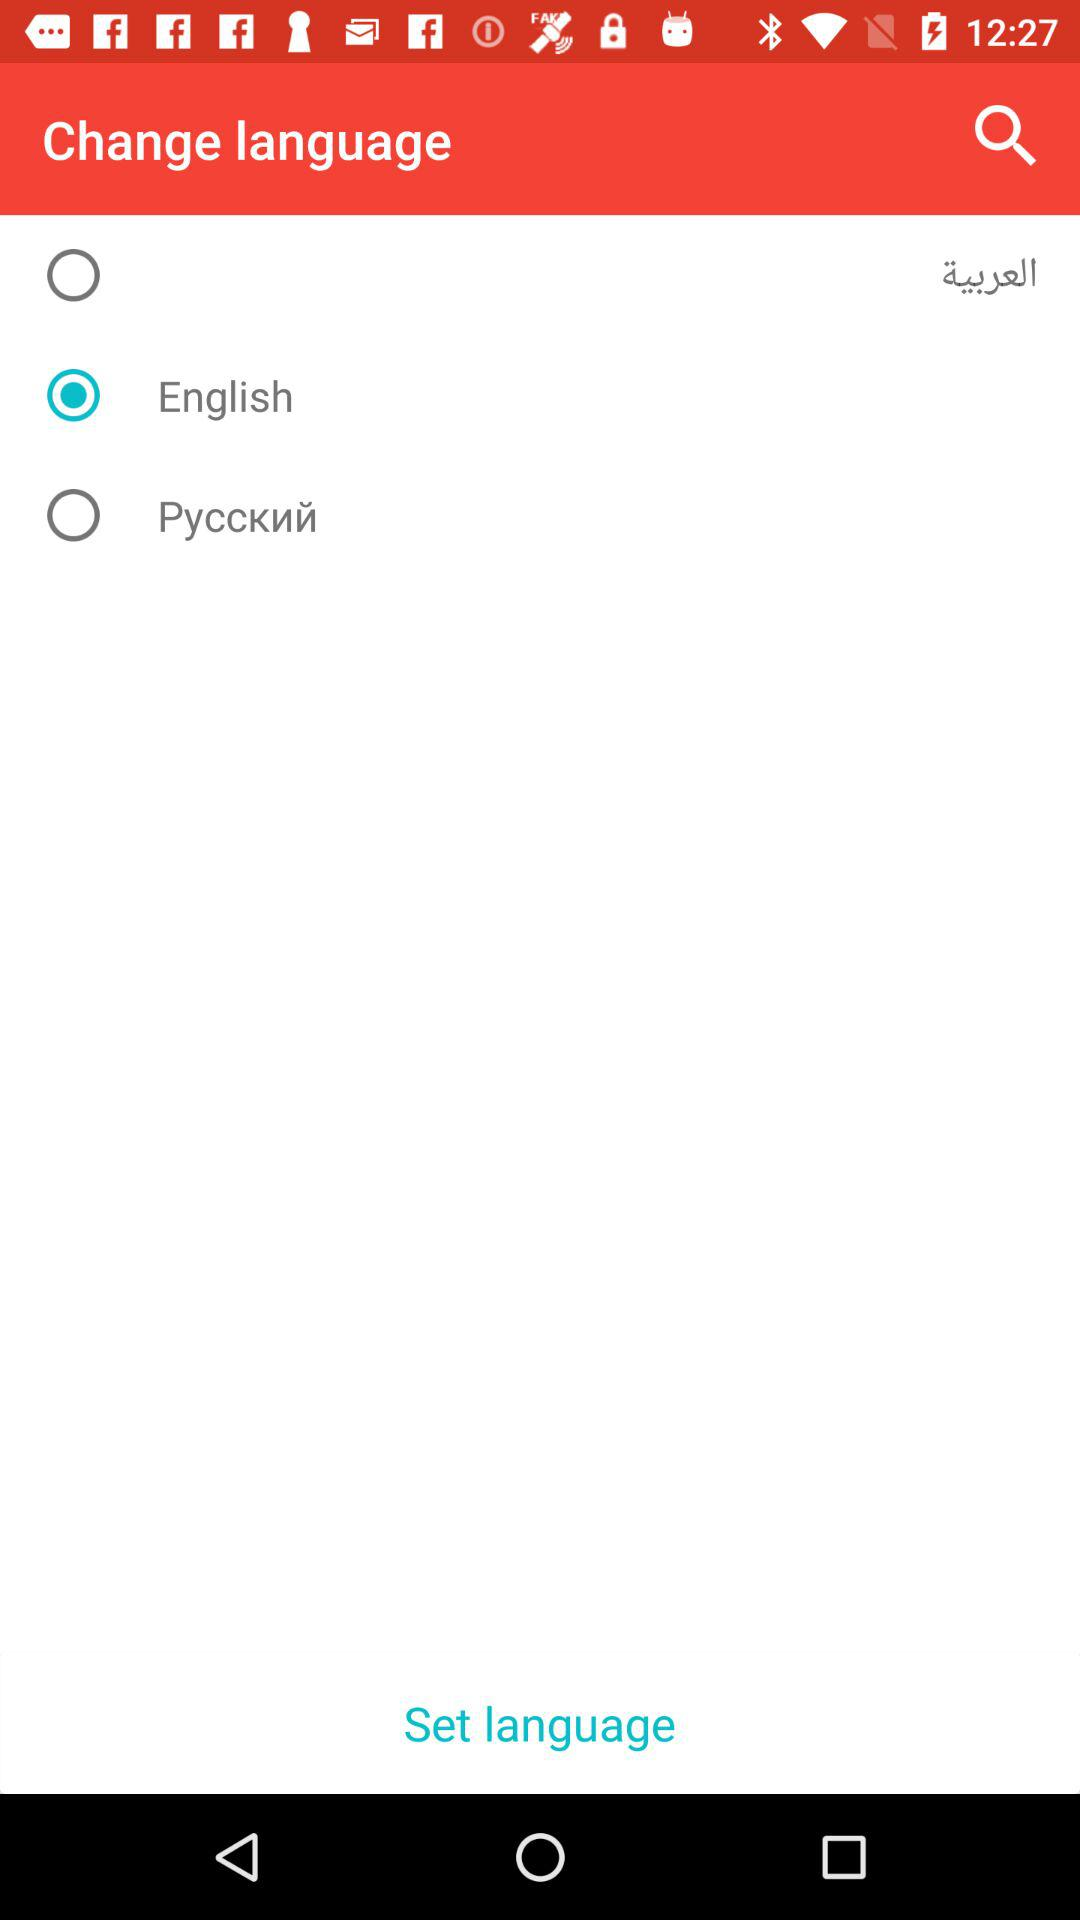Who is this application powered by?
When the provided information is insufficient, respond with <no answer>. <no answer> 